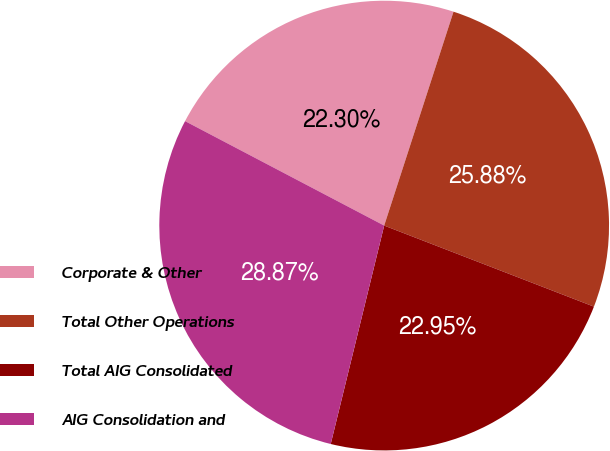Convert chart to OTSL. <chart><loc_0><loc_0><loc_500><loc_500><pie_chart><fcel>Corporate & Other<fcel>Total Other Operations<fcel>Total AIG Consolidated<fcel>AIG Consolidation and<nl><fcel>22.3%<fcel>25.88%<fcel>22.95%<fcel>28.87%<nl></chart> 